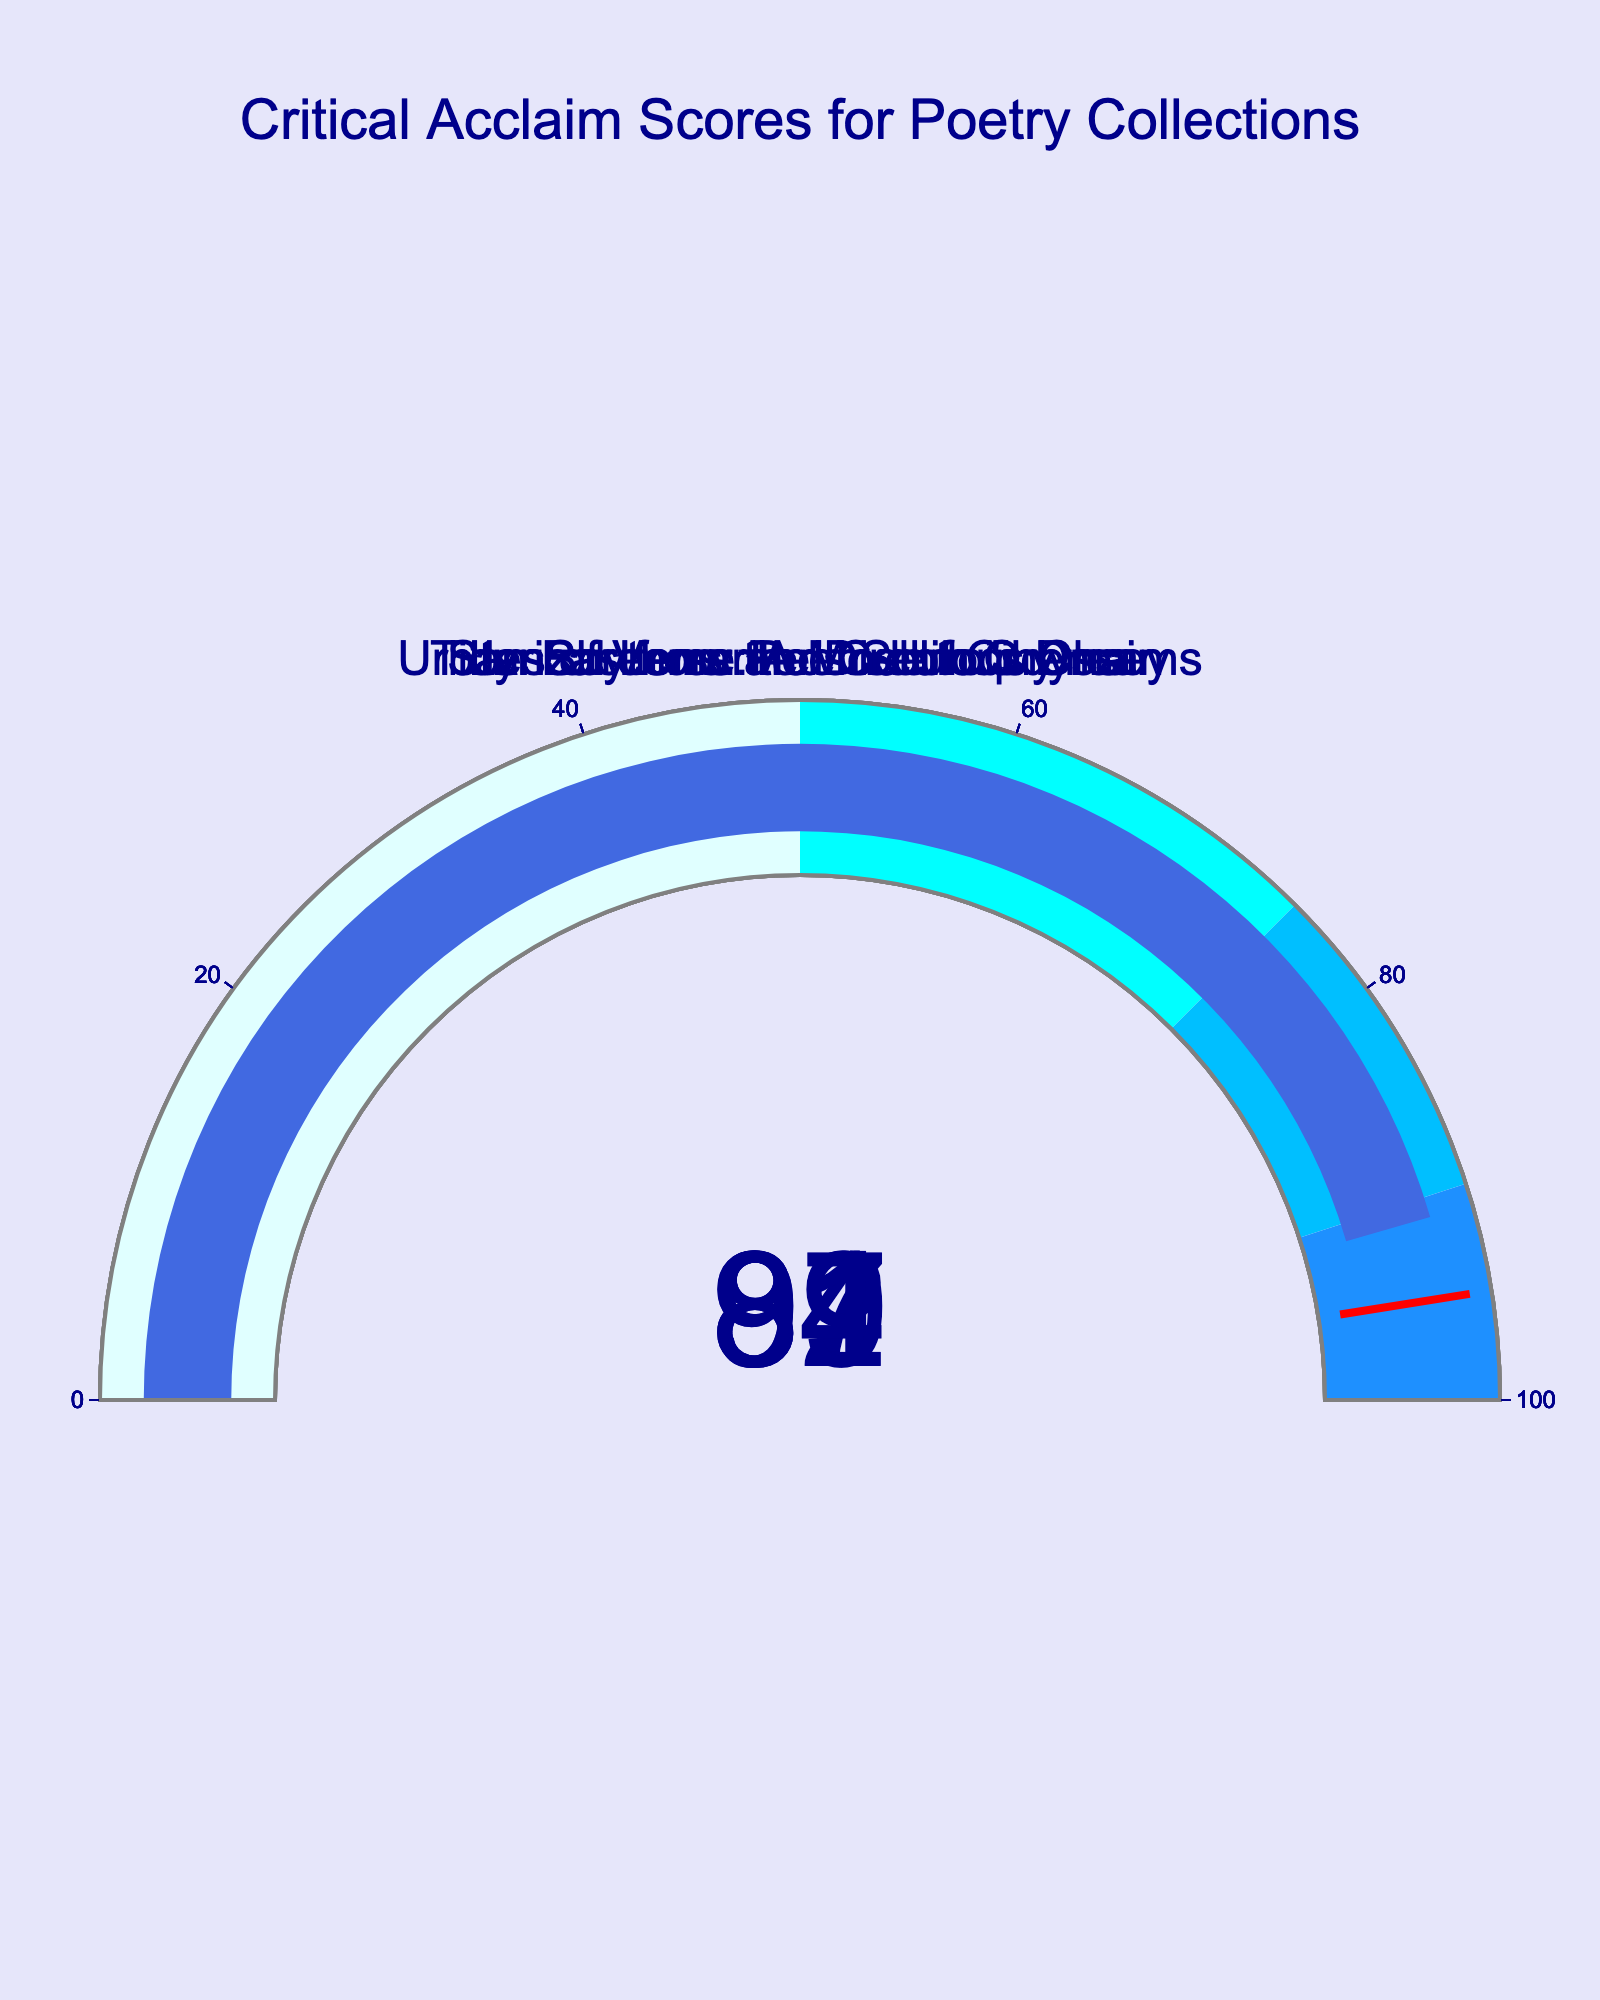What is the critical acclaim score for "Tides of Verse: A Modern Odyssey"? The figure shows each poetry collection title with its corresponding gauge chart. For "Tides of Verse: A Modern Odyssey", the value displayed on the gauge is 87.
Answer: 87 Which poetry collection received the highest critical acclaim score? To find the highest score, compare the values on each gauge. "Screenwriter's Soliloquy" has the highest score of 92.
Answer: "Screenwriter's Soliloquy" What is the difference in critical acclaim scores between "Stanzas from the Director's Chair" and "Urban Rhythms and Celluloid Dreams"? First, locate the scores for each collection on the gauges. "Stanzas from the Director's Chair" has a score of 89, and "Urban Rhythms and Celluloid Dreams" has a score of 84. The difference is 89 - 84.
Answer: 5 What is the average critical acclaim score for all poetry collections shown? Sum the scores of all collections and divide by the number of collections. The scores are 87, 92, 84, 89, and 91. The sum is 87 + 92 + 84 + 89 + 91 = 443. There are 5 collections, so the average is 443 / 5.
Answer: 88.6 How many poetry collections have a score above 90? Identify the gauges with scores above 90. "Screenwriter's Soliloquy" and "Lyrical Lens: Poems of Cinema" have scores of 92 and 91, respectively, making a total of 2 collections.
Answer: 2 What range of scores does the color ‘dodgerblue’ represent on the gauge chart? The gauge uses different colors to represent score ranges. Dodgerblue represents the range from 90 to 100 as seen in the legend of the gauge steps.
Answer: 90 to 100 Is the critical acclaim score for "Lyrical Lens: Poems of Cinema" higher than that of "Tides of Verse: A Modern Odyssey"? Compare the scores of the two collections. "Lyrical Lens: Poems of Cinema" has a score of 91, while "Tides of Verse: A Modern Odyssey" has a score of 87. 91 is higher than 87.
Answer: Yes What score acts as the threshold value marked by a red line on the gauge charts? All gauges show a red line indicating a specific threshold. The description states the threshold value is 95.
Answer: 95 